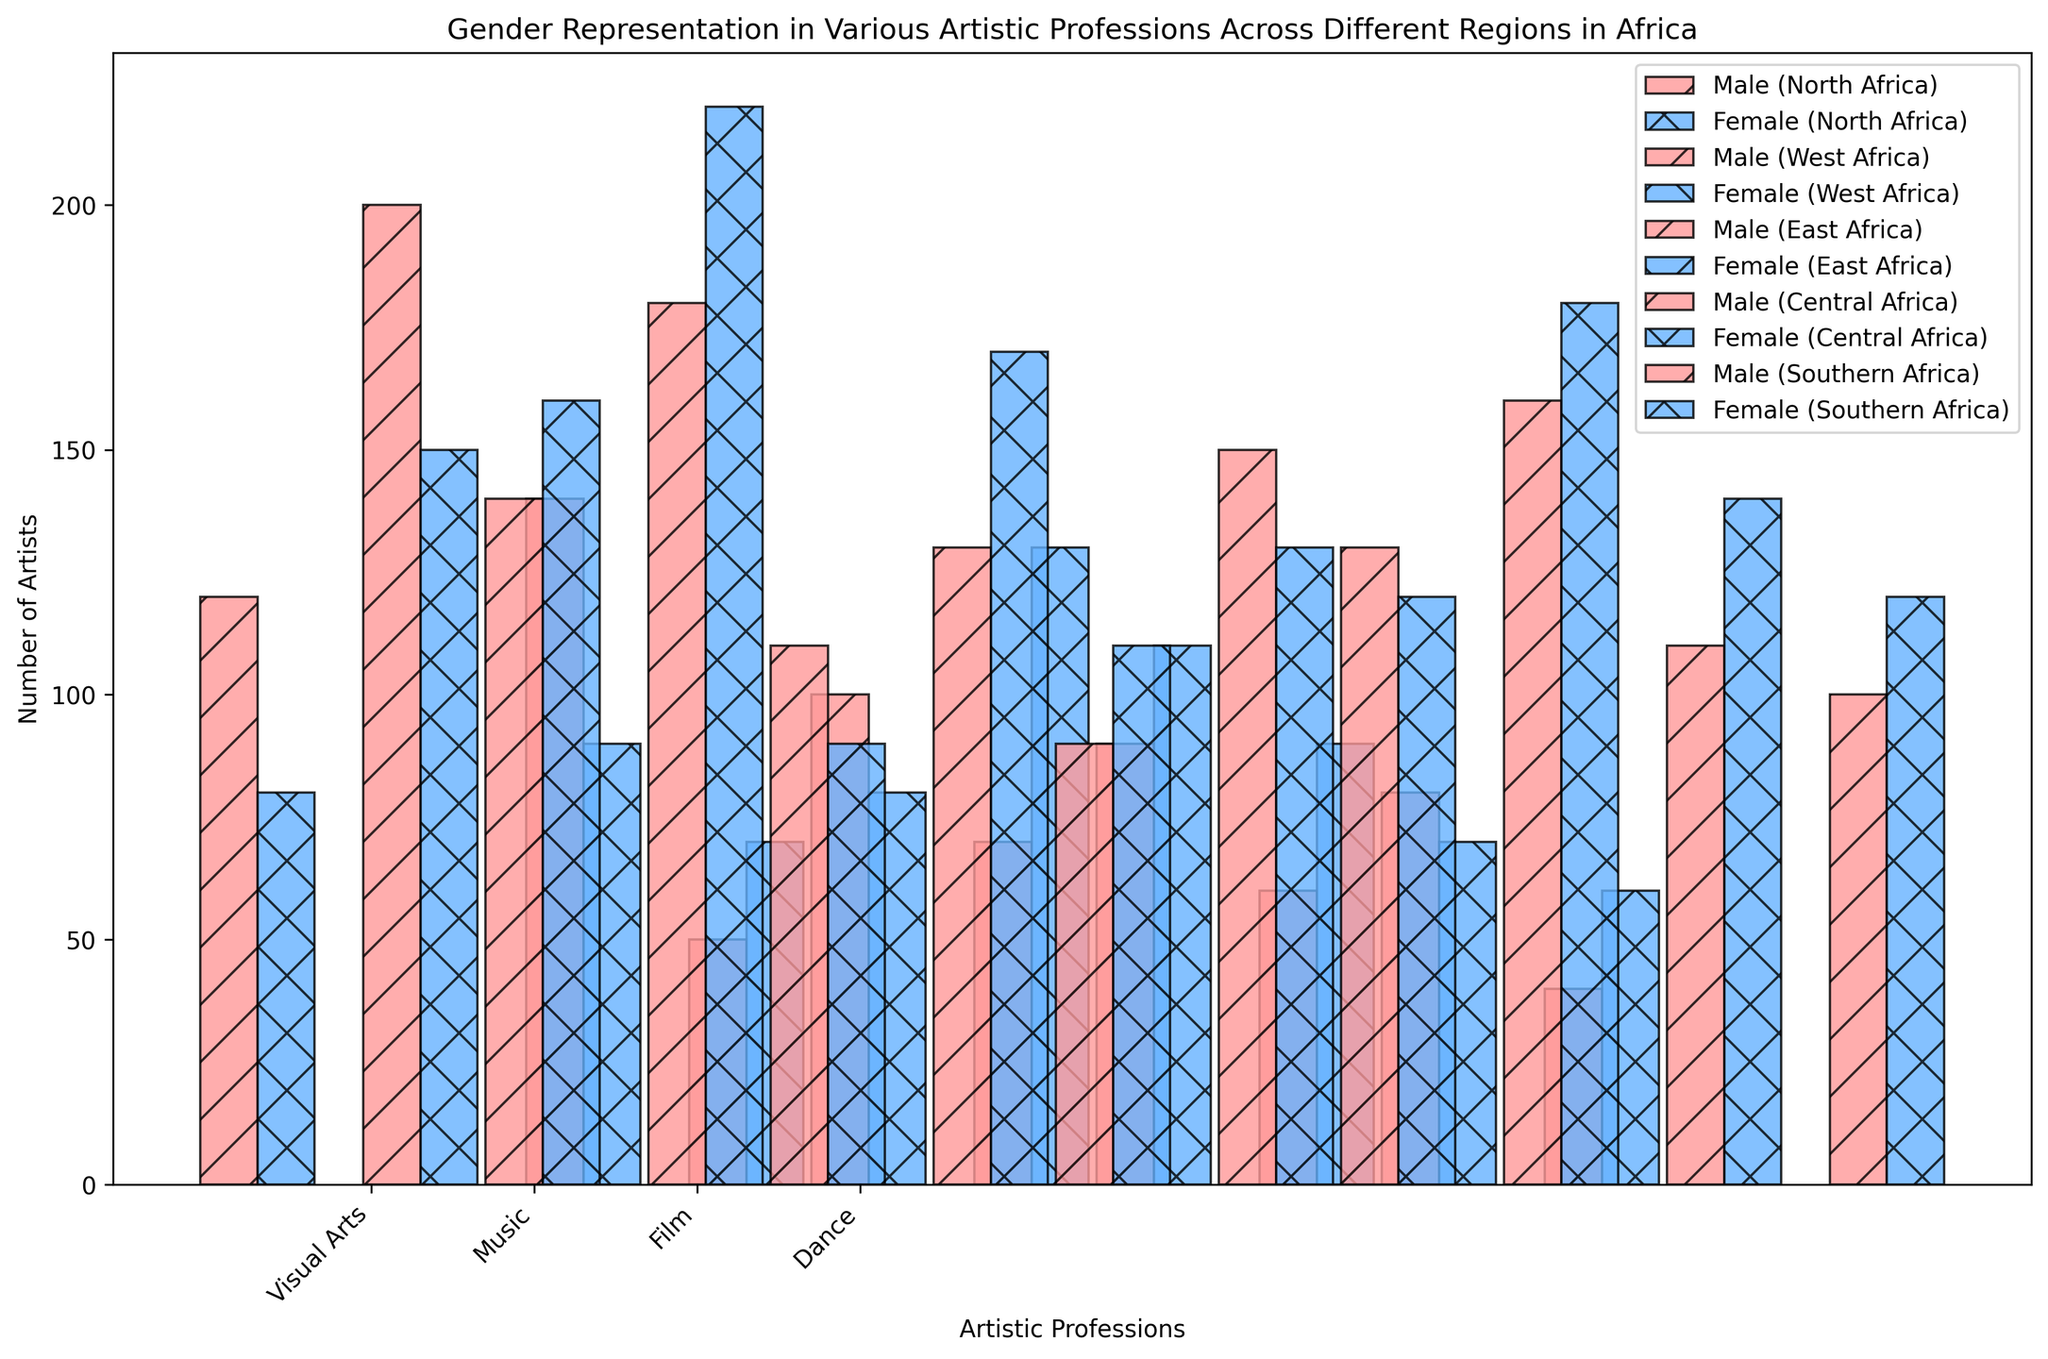Which region has the highest number of female musicians? From the plot, we can observe the height of the bars representing female musicians across the regions. The bar for female musicians in West Africa is the tallest among them all.
Answer: West Africa In which region is the gender disparity the least in the visual arts profession? To determine gender disparity, we need to look at the difference in height between the male and female bars for visual arts across regions. In Southern Africa, the male and female bars are almost equal in height, indicating minimal disparity.
Answer: Southern Africa How many more female dancers are there compared to male dancers in Southern Africa? Examine the heights of the bars representing male and female dancers in Southern Africa. The female dancer bar is higher. Calculate the difference: Female (120) - Male (100) = 20.
Answer: 20 Which profession in Central Africa has more female artists than male artists? Look for the profession in Central Africa where the female bar is taller than the male bar. This is observed in the visual arts profession.
Answer: Visual Arts What is the total number of musicians in East Africa? Sum the heights of the male and female bars for musicians in East Africa. Male (130) + Female (170) = 300.
Answer: 300 Which region has the largest number of male film artists? Compare the heights of the bars representing male film artists in all regions. The highest bar is in North Africa, representing the largest number.
Answer: North Africa In which artistic profession in West Africa is the female representation higher than the male representation? Check each profession in West Africa where the female bar exceeds the male bar in height. This occurs in Visual Arts, Music, and Dance.
Answer: Visual Arts, Music, Dance By how much does the number of female film artists in Southern Africa exceed that in Central Africa? Compare the heights of the female film artist bars in Southern and Central Africa. Southern Africa has 140, while Central Africa has 70. The difference is 140 - 70 = 70.
Answer: 70 Which profession in East Africa shows a reverse trend, with more male artists than female artists overall? Look for the profession in East Africa where the male bar is taller than the female bar. This is seen in the visual arts.
Answer: Visual Arts How many total visual artists are there in North Africa? Sum the heights of the male and female bars for visual artists in North Africa. Male (120) + Female (80) = 200.
Answer: 200 